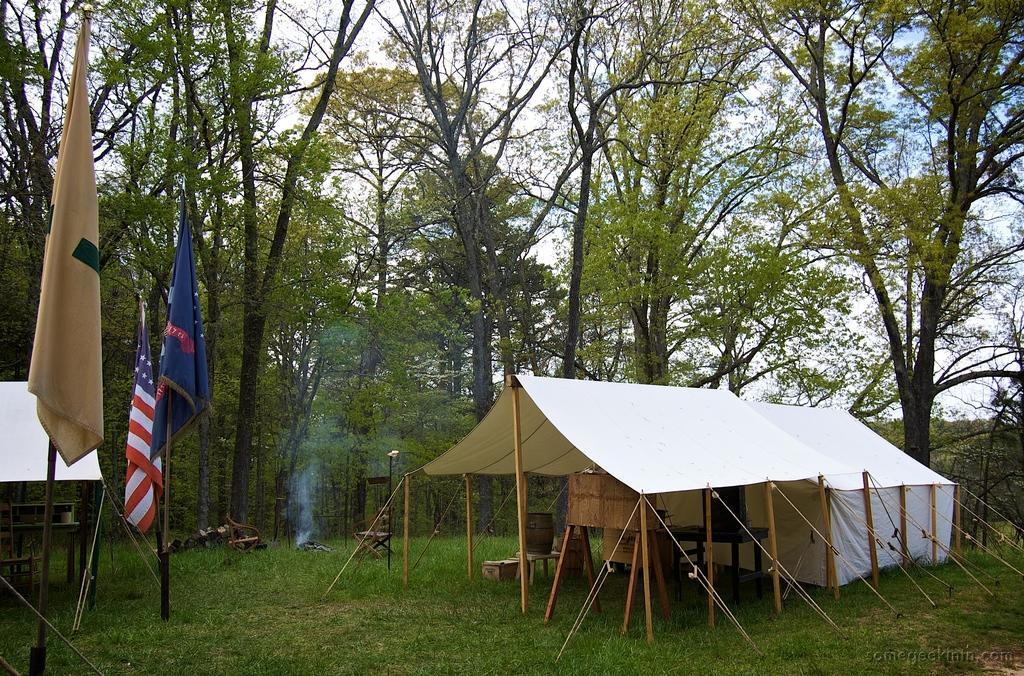How would you summarize this image in a sentence or two? In this image we can see there are tents. In the tents there are wooden sticks, table, speaker, chair, flags, and stand. And there are trees, grass and the sky. 